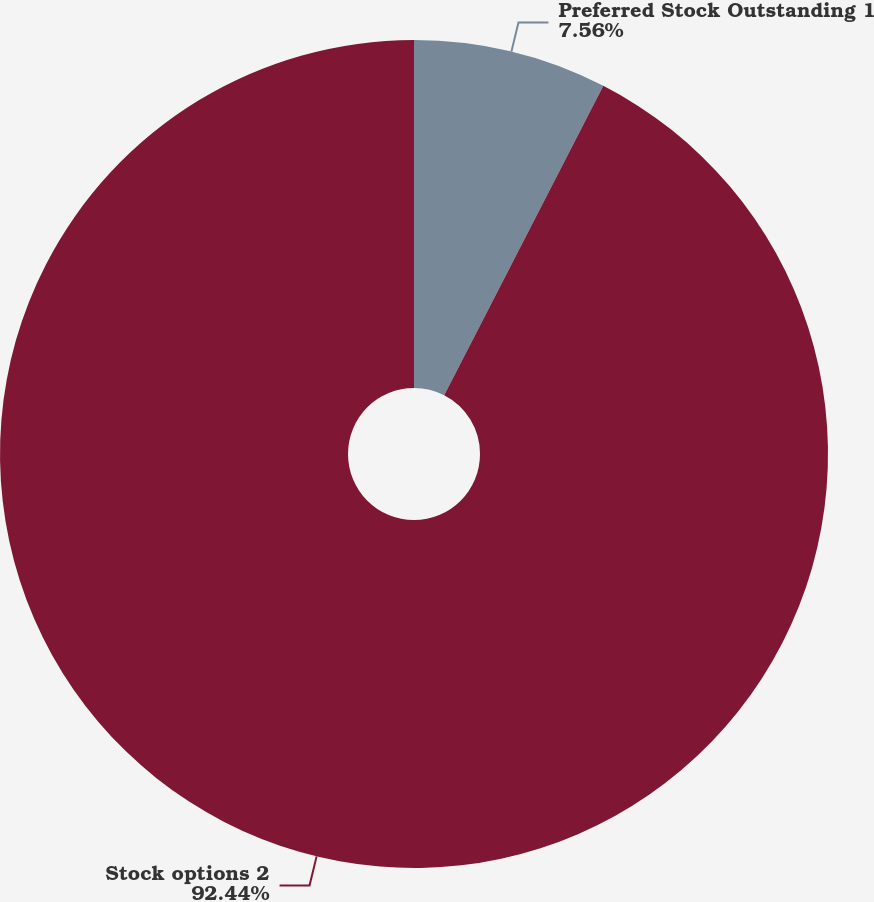Convert chart to OTSL. <chart><loc_0><loc_0><loc_500><loc_500><pie_chart><fcel>Preferred Stock Outstanding 1<fcel>Stock options 2<nl><fcel>7.56%<fcel>92.44%<nl></chart> 